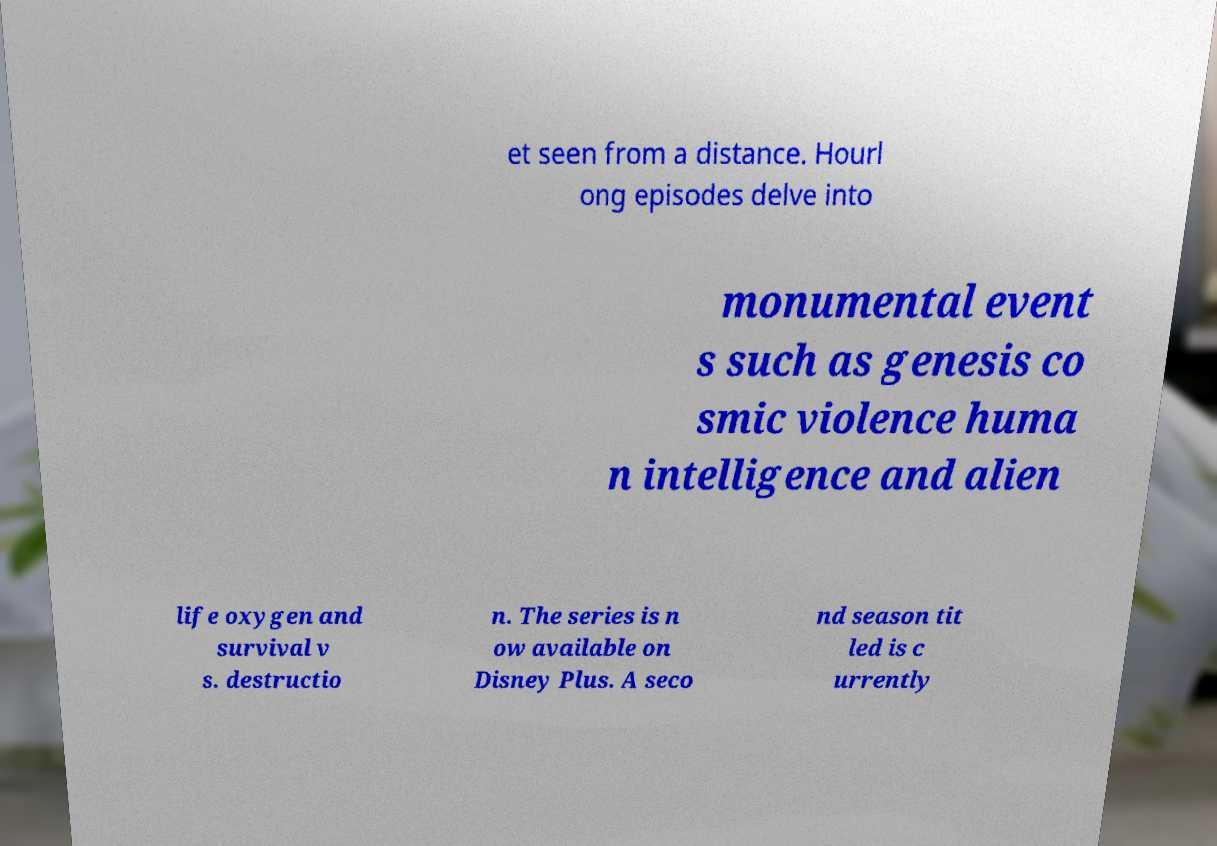Can you accurately transcribe the text from the provided image for me? et seen from a distance. Hourl ong episodes delve into monumental event s such as genesis co smic violence huma n intelligence and alien life oxygen and survival v s. destructio n. The series is n ow available on Disney Plus. A seco nd season tit led is c urrently 